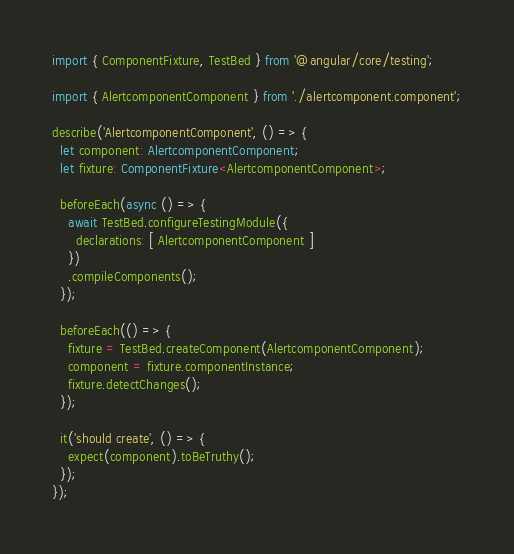<code> <loc_0><loc_0><loc_500><loc_500><_TypeScript_>import { ComponentFixture, TestBed } from '@angular/core/testing';

import { AlertcomponentComponent } from './alertcomponent.component';

describe('AlertcomponentComponent', () => {
  let component: AlertcomponentComponent;
  let fixture: ComponentFixture<AlertcomponentComponent>;

  beforeEach(async () => {
    await TestBed.configureTestingModule({
      declarations: [ AlertcomponentComponent ]
    })
    .compileComponents();
  });

  beforeEach(() => {
    fixture = TestBed.createComponent(AlertcomponentComponent);
    component = fixture.componentInstance;
    fixture.detectChanges();
  });

  it('should create', () => {
    expect(component).toBeTruthy();
  });
});
</code> 